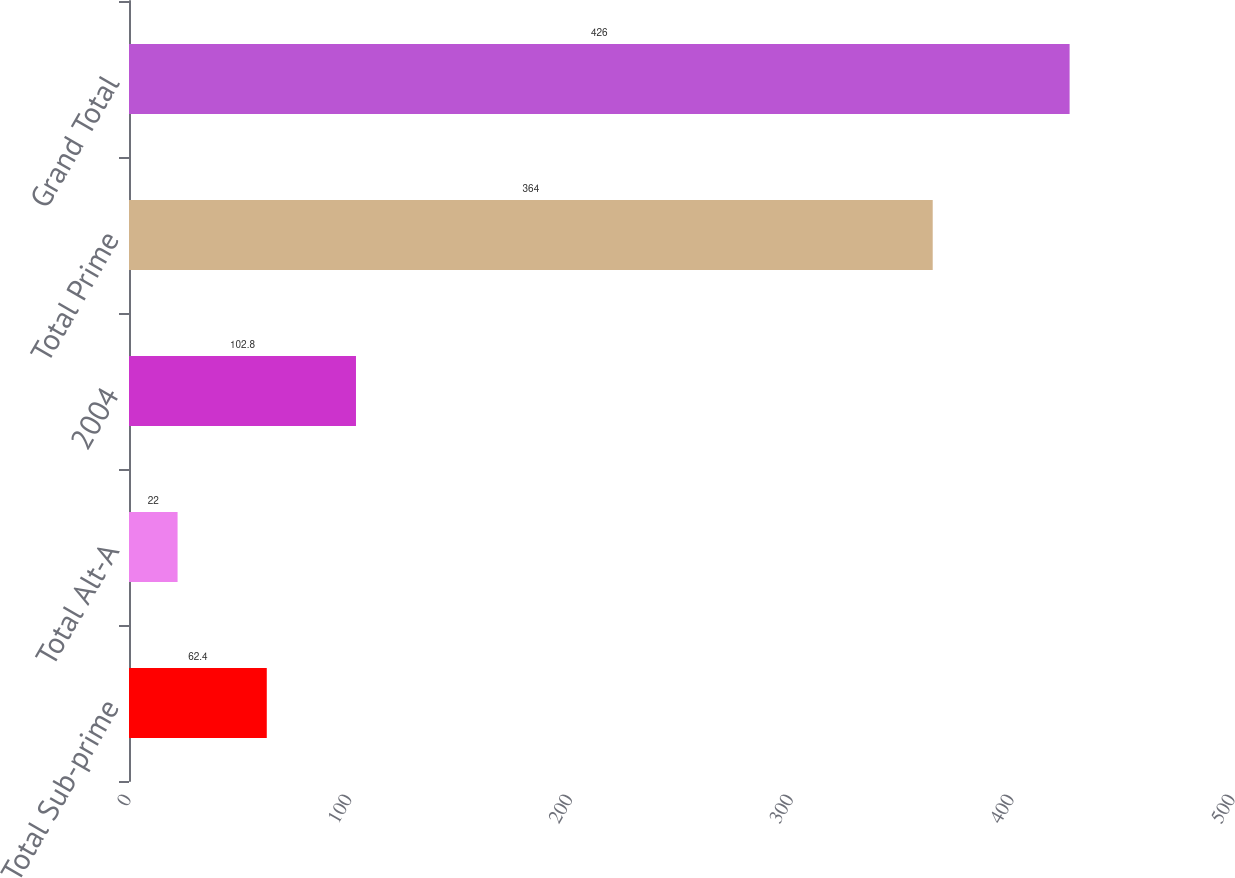Convert chart. <chart><loc_0><loc_0><loc_500><loc_500><bar_chart><fcel>Total Sub-prime<fcel>Total Alt-A<fcel>2004<fcel>Total Prime<fcel>Grand Total<nl><fcel>62.4<fcel>22<fcel>102.8<fcel>364<fcel>426<nl></chart> 